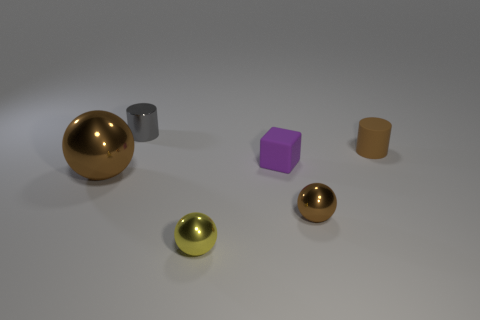Subtract all small yellow spheres. How many spheres are left? 2 Subtract all brown balls. How many balls are left? 1 Subtract 1 cylinders. How many cylinders are left? 1 Add 3 yellow shiny spheres. How many objects exist? 9 Subtract all cylinders. How many objects are left? 4 Subtract 0 green cubes. How many objects are left? 6 Subtract all cyan cylinders. Subtract all brown cubes. How many cylinders are left? 2 Subtract all cyan balls. How many gray cylinders are left? 1 Subtract all large red metallic cubes. Subtract all large brown objects. How many objects are left? 5 Add 5 brown balls. How many brown balls are left? 7 